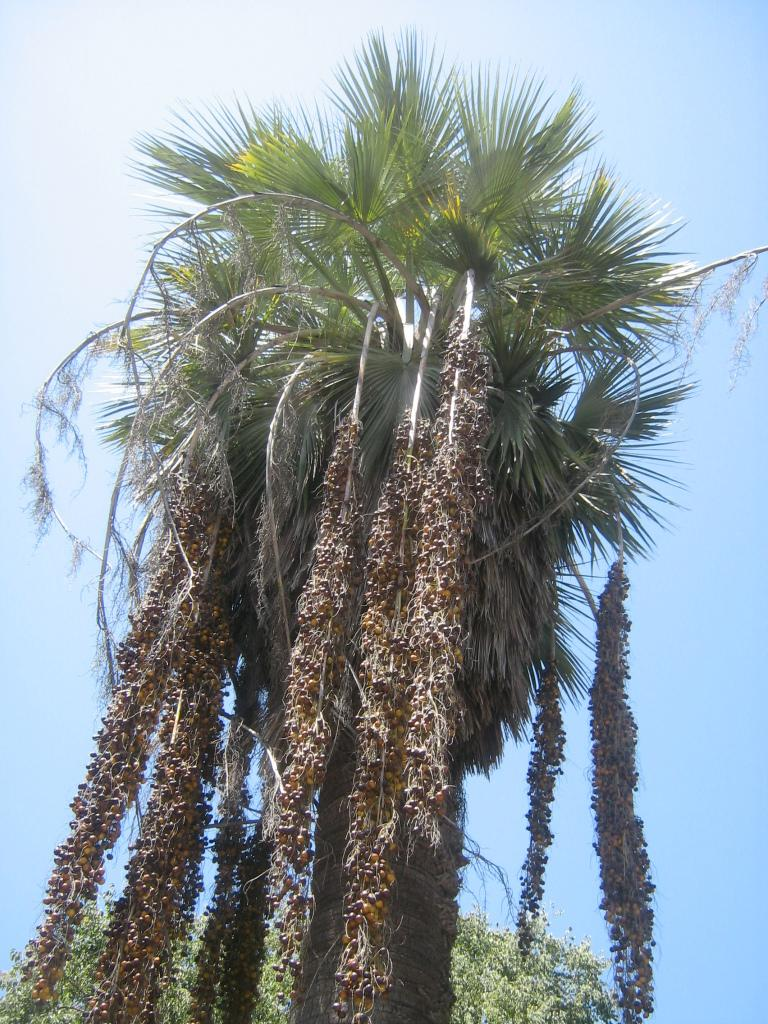What type of vegetation can be seen in the image? There are trees in the image. What part of the natural environment is visible in the image? The sky is visible in the background of the image. What type of straw is being used to decorate the flowers in the image? There are no flowers or straw present in the image; it only features trees and the sky. 